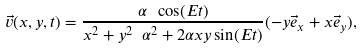<formula> <loc_0><loc_0><loc_500><loc_500>\vec { v } ( x , y , t ) = \frac { \alpha \ \cos ( E t ) } { x ^ { 2 } + y ^ { 2 } \ \alpha ^ { 2 } + 2 \alpha x y \sin ( E t ) } ( - y \vec { e } _ { x } + x \vec { e } _ { y } ) ,</formula> 